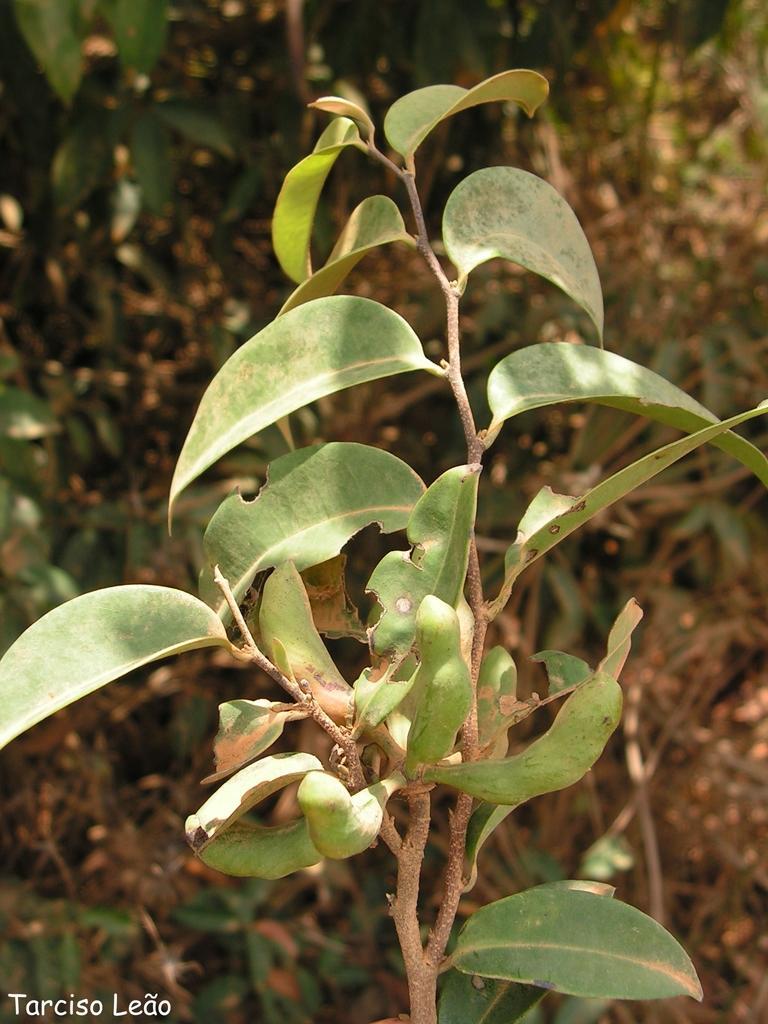In one or two sentences, can you explain what this image depicts? In the center of the image we can see a plant. In the background we can see the dried leaves and also the plants. In the bottom left corner we can see the text. 